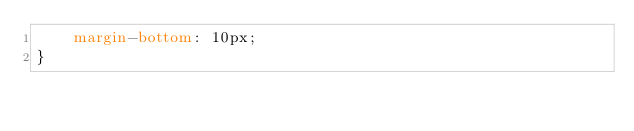<code> <loc_0><loc_0><loc_500><loc_500><_CSS_>	margin-bottom: 10px;
}
</code> 